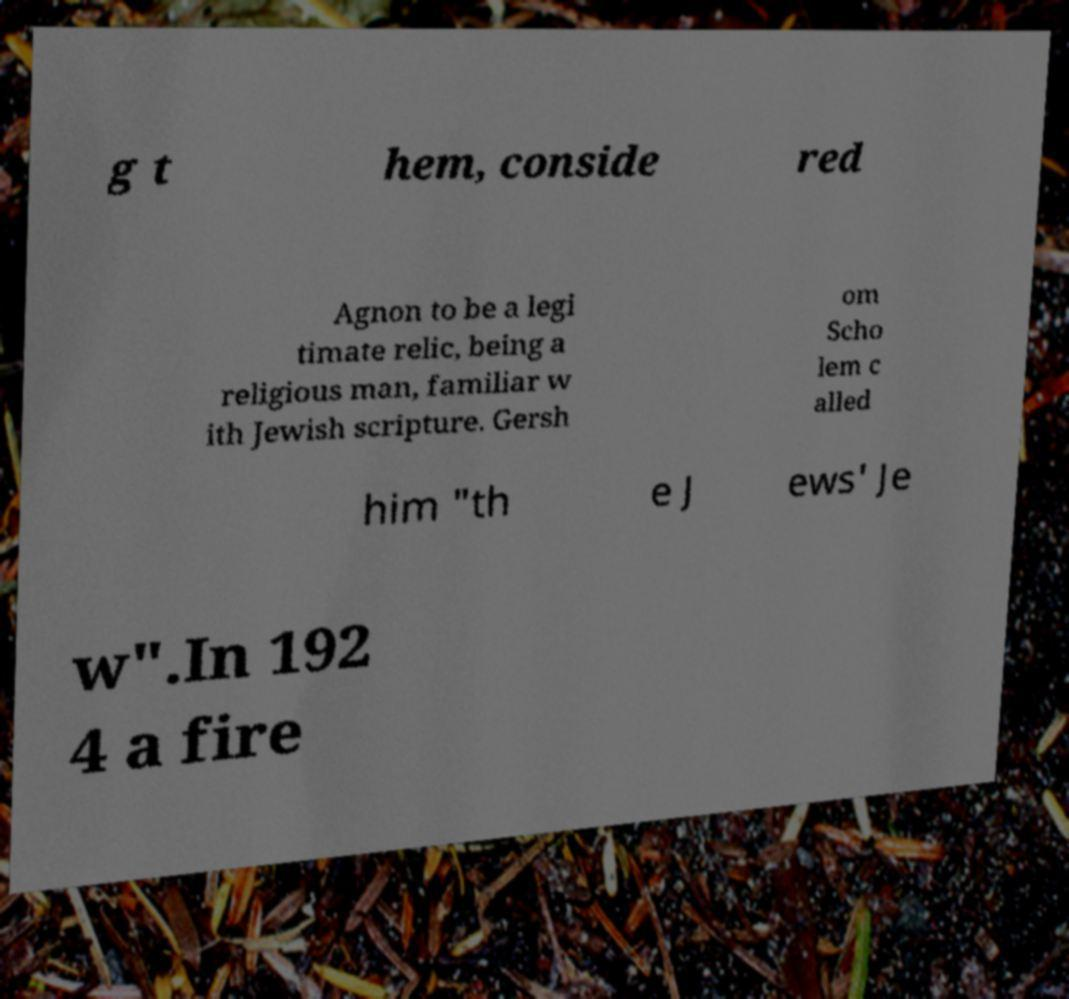There's text embedded in this image that I need extracted. Can you transcribe it verbatim? g t hem, conside red Agnon to be a legi timate relic, being a religious man, familiar w ith Jewish scripture. Gersh om Scho lem c alled him "th e J ews' Je w".In 192 4 a fire 